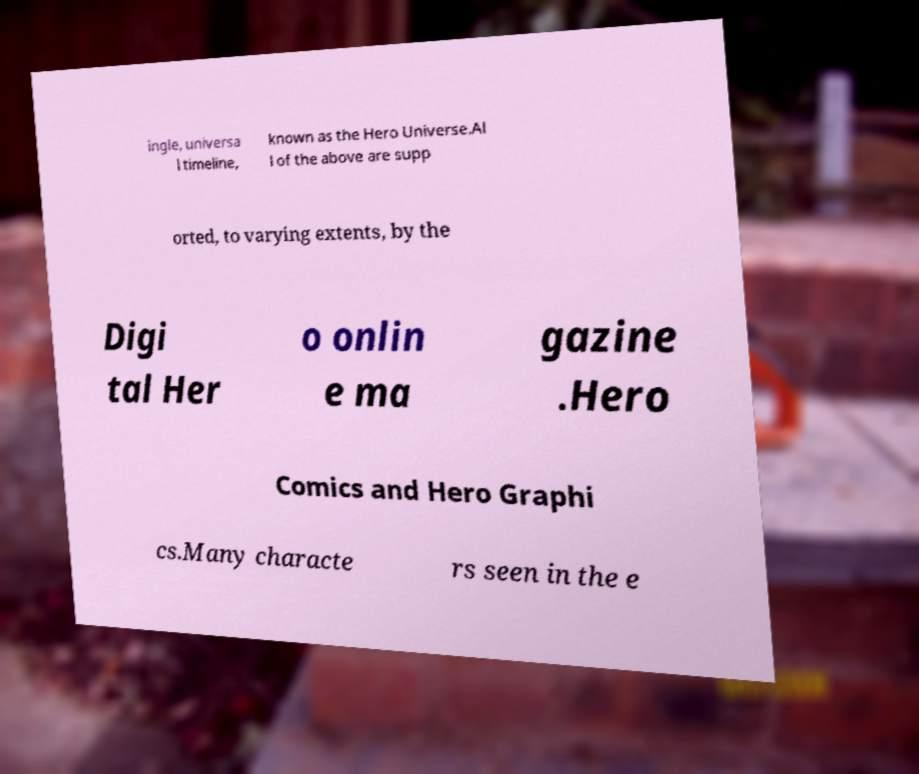Could you assist in decoding the text presented in this image and type it out clearly? ingle, universa l timeline, known as the Hero Universe.Al l of the above are supp orted, to varying extents, by the Digi tal Her o onlin e ma gazine .Hero Comics and Hero Graphi cs.Many characte rs seen in the e 